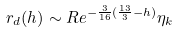Convert formula to latex. <formula><loc_0><loc_0><loc_500><loc_500>r _ { d } ( h ) \sim R e ^ { - \frac { 3 } { 1 6 } ( \frac { 1 3 } { 3 } - h ) } \eta _ { k }</formula> 